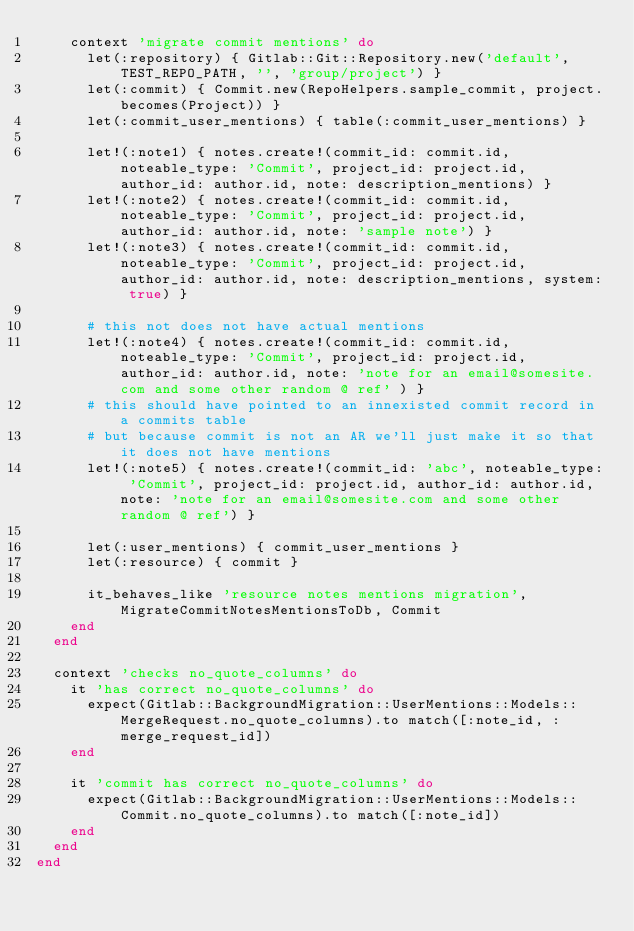<code> <loc_0><loc_0><loc_500><loc_500><_Ruby_>    context 'migrate commit mentions' do
      let(:repository) { Gitlab::Git::Repository.new('default', TEST_REPO_PATH, '', 'group/project') }
      let(:commit) { Commit.new(RepoHelpers.sample_commit, project.becomes(Project)) }
      let(:commit_user_mentions) { table(:commit_user_mentions) }

      let!(:note1) { notes.create!(commit_id: commit.id, noteable_type: 'Commit', project_id: project.id, author_id: author.id, note: description_mentions) }
      let!(:note2) { notes.create!(commit_id: commit.id, noteable_type: 'Commit', project_id: project.id, author_id: author.id, note: 'sample note') }
      let!(:note3) { notes.create!(commit_id: commit.id, noteable_type: 'Commit', project_id: project.id, author_id: author.id, note: description_mentions, system: true) }

      # this not does not have actual mentions
      let!(:note4) { notes.create!(commit_id: commit.id, noteable_type: 'Commit', project_id: project.id, author_id: author.id, note: 'note for an email@somesite.com and some other random @ ref' ) }
      # this should have pointed to an innexisted commit record in a commits table
      # but because commit is not an AR we'll just make it so that it does not have mentions
      let!(:note5) { notes.create!(commit_id: 'abc', noteable_type: 'Commit', project_id: project.id, author_id: author.id, note: 'note for an email@somesite.com and some other random @ ref') }

      let(:user_mentions) { commit_user_mentions }
      let(:resource) { commit }

      it_behaves_like 'resource notes mentions migration', MigrateCommitNotesMentionsToDb, Commit
    end
  end

  context 'checks no_quote_columns' do
    it 'has correct no_quote_columns' do
      expect(Gitlab::BackgroundMigration::UserMentions::Models::MergeRequest.no_quote_columns).to match([:note_id, :merge_request_id])
    end

    it 'commit has correct no_quote_columns' do
      expect(Gitlab::BackgroundMigration::UserMentions::Models::Commit.no_quote_columns).to match([:note_id])
    end
  end
end
</code> 